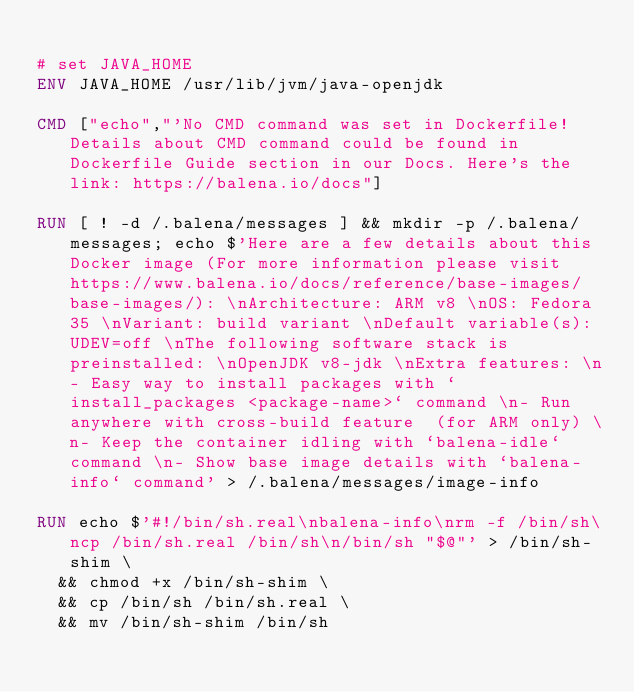<code> <loc_0><loc_0><loc_500><loc_500><_Dockerfile_>
# set JAVA_HOME
ENV JAVA_HOME /usr/lib/jvm/java-openjdk

CMD ["echo","'No CMD command was set in Dockerfile! Details about CMD command could be found in Dockerfile Guide section in our Docs. Here's the link: https://balena.io/docs"]

RUN [ ! -d /.balena/messages ] && mkdir -p /.balena/messages; echo $'Here are a few details about this Docker image (For more information please visit https://www.balena.io/docs/reference/base-images/base-images/): \nArchitecture: ARM v8 \nOS: Fedora 35 \nVariant: build variant \nDefault variable(s): UDEV=off \nThe following software stack is preinstalled: \nOpenJDK v8-jdk \nExtra features: \n- Easy way to install packages with `install_packages <package-name>` command \n- Run anywhere with cross-build feature  (for ARM only) \n- Keep the container idling with `balena-idle` command \n- Show base image details with `balena-info` command' > /.balena/messages/image-info

RUN echo $'#!/bin/sh.real\nbalena-info\nrm -f /bin/sh\ncp /bin/sh.real /bin/sh\n/bin/sh "$@"' > /bin/sh-shim \
	&& chmod +x /bin/sh-shim \
	&& cp /bin/sh /bin/sh.real \
	&& mv /bin/sh-shim /bin/sh</code> 